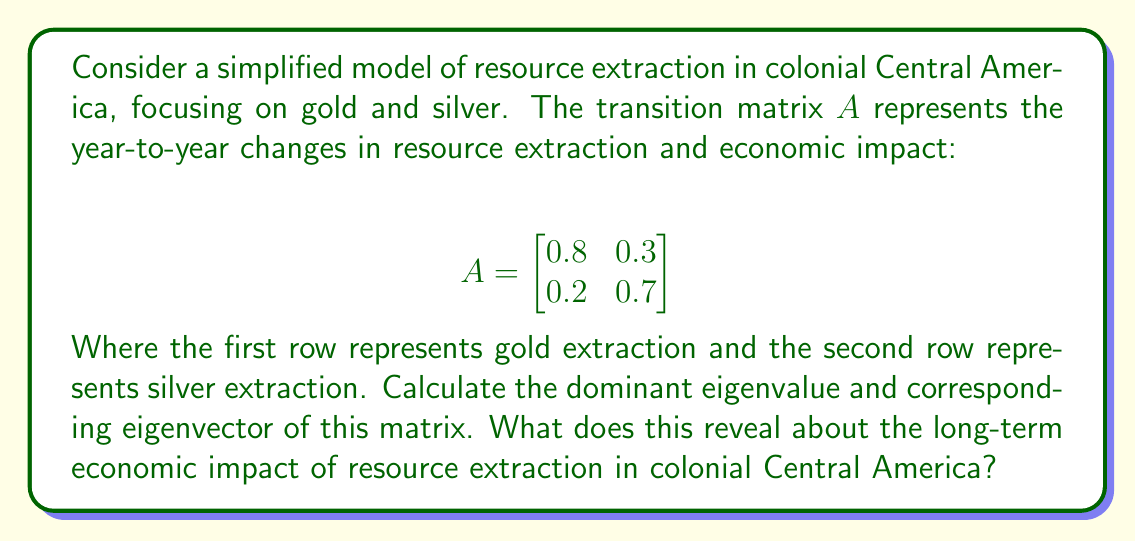Solve this math problem. To solve this problem, we'll follow these steps:

1) Find the characteristic equation of matrix $A$
2) Solve for the eigenvalues
3) Find the corresponding eigenvectors
4) Interpret the results

Step 1: Characteristic equation

The characteristic equation is given by $det(A - \lambda I) = 0$

$$det\begin{pmatrix}
0.8-\lambda & 0.3 \\
0.2 & 0.7-\lambda
\end{pmatrix} = 0$$

$(0.8-\lambda)(0.7-\lambda) - 0.06 = 0$

$\lambda^2 - 1.5\lambda + 0.5 = 0$

Step 2: Solve for eigenvalues

Using the quadratic formula, we get:

$\lambda = \frac{1.5 \pm \sqrt{1.5^2 - 4(0.5)}}{2}$

$\lambda_1 = 1$ and $\lambda_2 = 0.5$

The dominant eigenvalue is $\lambda_1 = 1$

Step 3: Find the corresponding eigenvector

For $\lambda_1 = 1$, we solve $(A - I)v = 0$:

$$\begin{bmatrix}
-0.2 & 0.3 \\
0.2 & -0.3
\end{bmatrix}\begin{bmatrix}
v_1 \\
v_2
\end{bmatrix} = \begin{bmatrix}
0 \\
0
\end{bmatrix}$$

This gives us $v_1 = 3v_2$. We can choose $v_2 = 1$ for simplicity.

The dominant eigenvector is therefore $v = \begin{bmatrix} 3 \\ 1 \end{bmatrix}$

Step 4: Interpretation

The dominant eigenvalue of 1 indicates that the overall extraction level remains stable in the long term. The corresponding eigenvector $[3, 1]^T$ suggests that the stable state has a 3:1 ratio of gold to silver extraction impact. This implies that gold extraction had a more significant long-term economic impact than silver in colonial Central America, according to this simplified model.
Answer: Dominant eigenvalue: $\lambda_1 = 1$
Corresponding eigenvector: $v = \begin{bmatrix} 3 \\ 1 \end{bmatrix}$

This indicates a stable long-term extraction level with gold having three times the economic impact of silver in colonial Central America. 